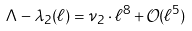<formula> <loc_0><loc_0><loc_500><loc_500>\Lambda - \lambda _ { 2 } ( \ell ) & = \nu _ { 2 } \cdot \ell ^ { 8 } + \mathcal { O } ( \ell ^ { 5 } )</formula> 